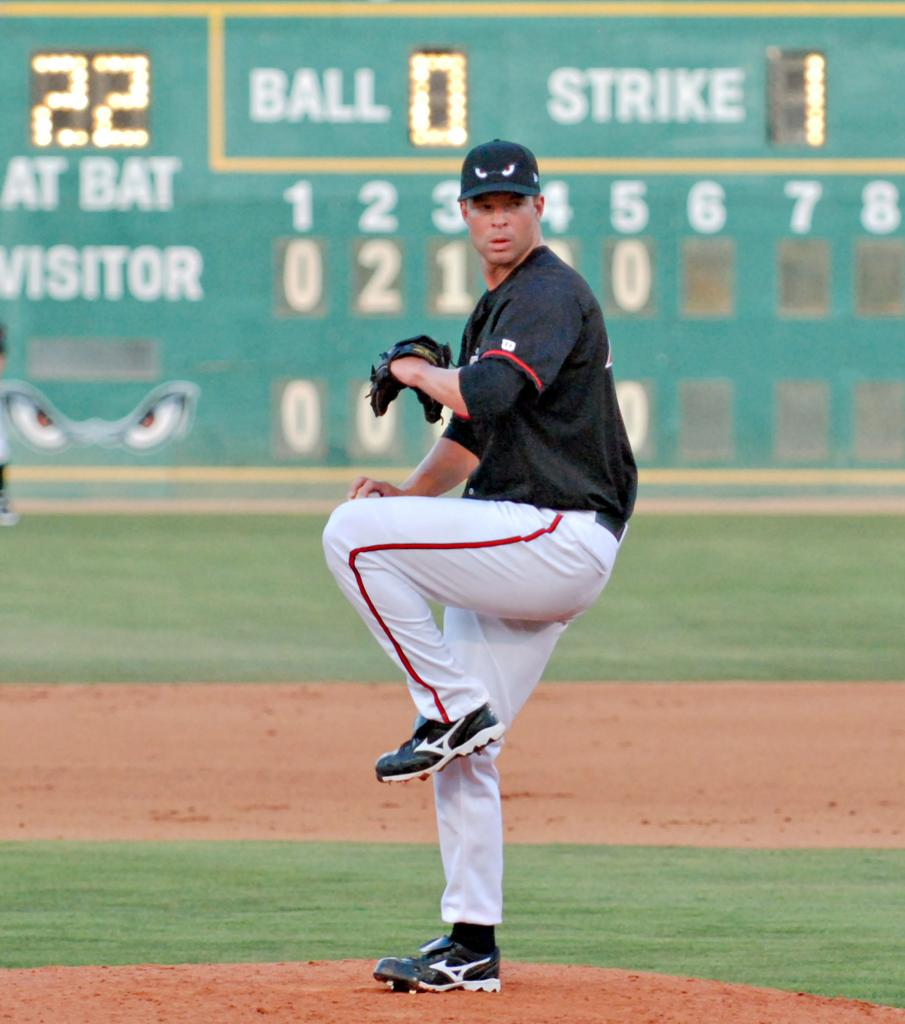<image>
Summarize the visual content of the image. A pitcher is about to throw the ball in the sixth inning with one strike and no balls for the batter. 